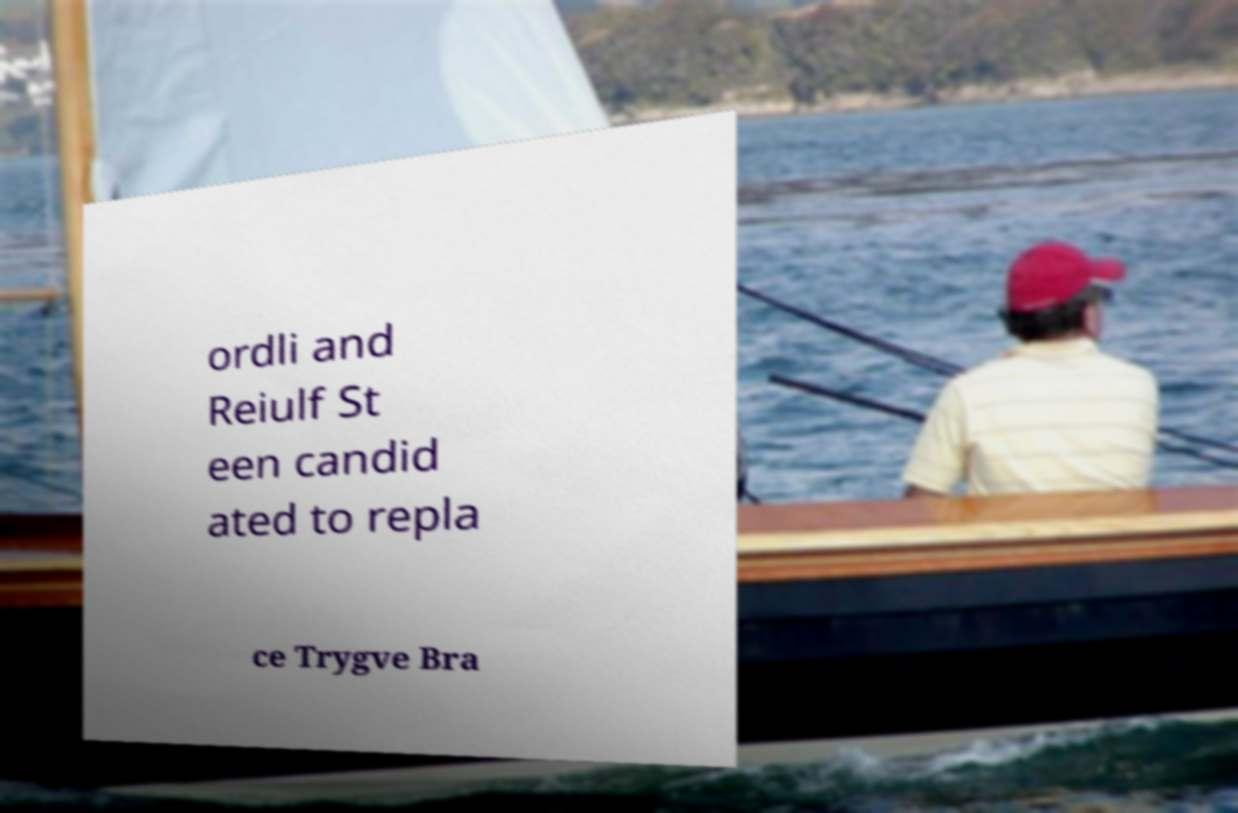For documentation purposes, I need the text within this image transcribed. Could you provide that? ordli and Reiulf St een candid ated to repla ce Trygve Bra 